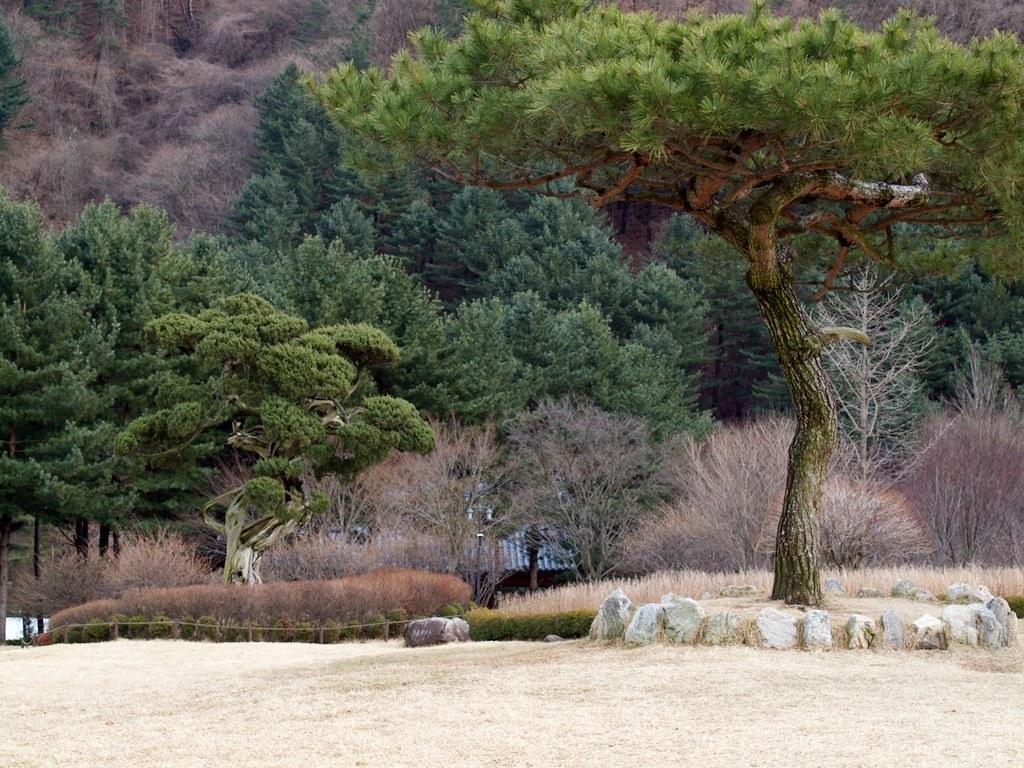Could you give a brief overview of what you see in this image? To the bottom of the image there is a ground. And to the right corner of the image there is a tree with stones boundary. And in the background there are many trees and grass on the ground. 